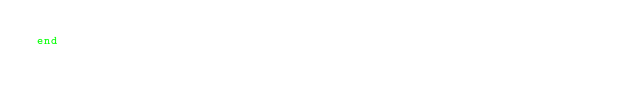<code> <loc_0><loc_0><loc_500><loc_500><_Ruby_>end
</code> 